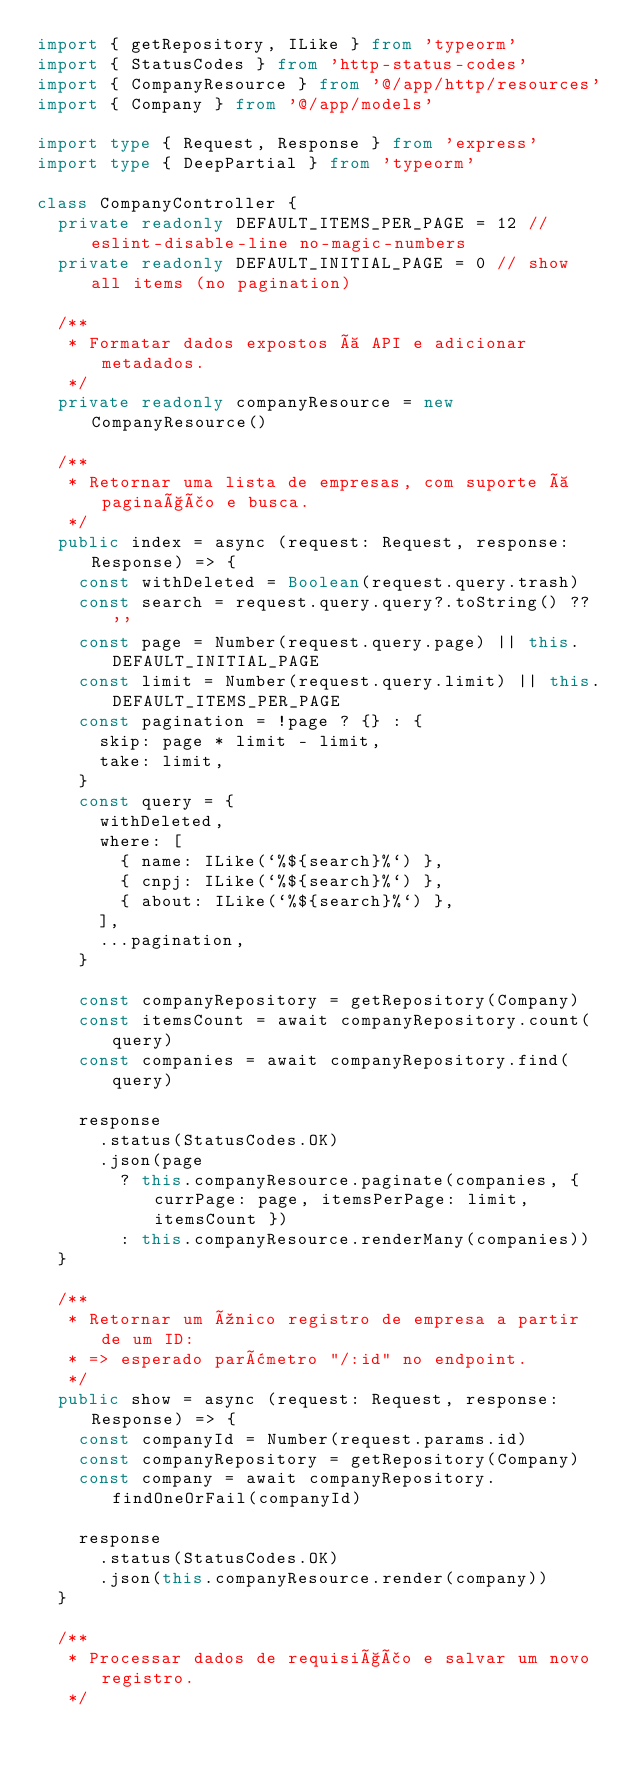Convert code to text. <code><loc_0><loc_0><loc_500><loc_500><_TypeScript_>import { getRepository, ILike } from 'typeorm'
import { StatusCodes } from 'http-status-codes'
import { CompanyResource } from '@/app/http/resources'
import { Company } from '@/app/models'

import type { Request, Response } from 'express'
import type { DeepPartial } from 'typeorm'

class CompanyController {
  private readonly DEFAULT_ITEMS_PER_PAGE = 12 // eslint-disable-line no-magic-numbers
  private readonly DEFAULT_INITIAL_PAGE = 0 // show all items (no pagination)

  /**
   * Formatar dados expostos à API e adicionar metadados.
   */
  private readonly companyResource = new CompanyResource()

  /**
   * Retornar uma lista de empresas, com suporte à paginação e busca.
   */
  public index = async (request: Request, response: Response) => {
    const withDeleted = Boolean(request.query.trash)
    const search = request.query.query?.toString() ?? ''
    const page = Number(request.query.page) || this.DEFAULT_INITIAL_PAGE
    const limit = Number(request.query.limit) || this.DEFAULT_ITEMS_PER_PAGE
    const pagination = !page ? {} : {
      skip: page * limit - limit,
      take: limit,
    }
    const query = {
      withDeleted,
      where: [
        { name: ILike(`%${search}%`) },
        { cnpj: ILike(`%${search}%`) },
        { about: ILike(`%${search}%`) },
      ],
      ...pagination,
    }

    const companyRepository = getRepository(Company)
    const itemsCount = await companyRepository.count(query)
    const companies = await companyRepository.find(query)

    response
      .status(StatusCodes.OK)
      .json(page
        ? this.companyResource.paginate(companies, { currPage: page, itemsPerPage: limit, itemsCount })
        : this.companyResource.renderMany(companies))
  }

  /**
   * Retornar um único registro de empresa a partir de um ID:
   * => esperado parâmetro "/:id" no endpoint.
   */
  public show = async (request: Request, response: Response) => {
    const companyId = Number(request.params.id)
    const companyRepository = getRepository(Company)
    const company = await companyRepository.findOneOrFail(companyId)

    response
      .status(StatusCodes.OK)
      .json(this.companyResource.render(company))
  }

  /**
   * Processar dados de requisição e salvar um novo registro.
   */</code> 